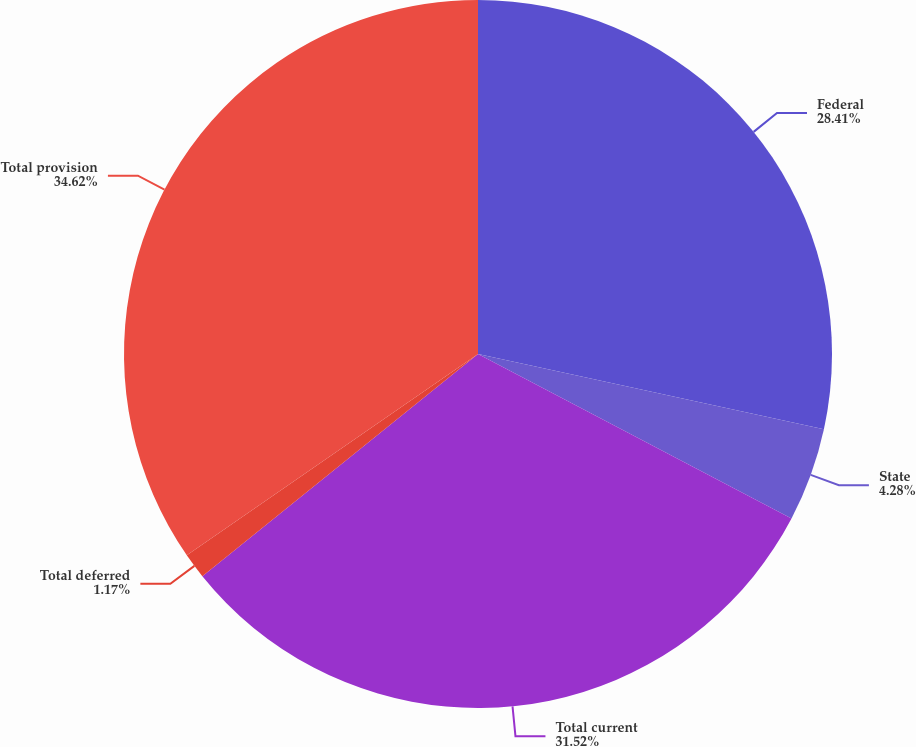Convert chart. <chart><loc_0><loc_0><loc_500><loc_500><pie_chart><fcel>Federal<fcel>State<fcel>Total current<fcel>Total deferred<fcel>Total provision<nl><fcel>28.41%<fcel>4.28%<fcel>31.52%<fcel>1.17%<fcel>34.63%<nl></chart> 